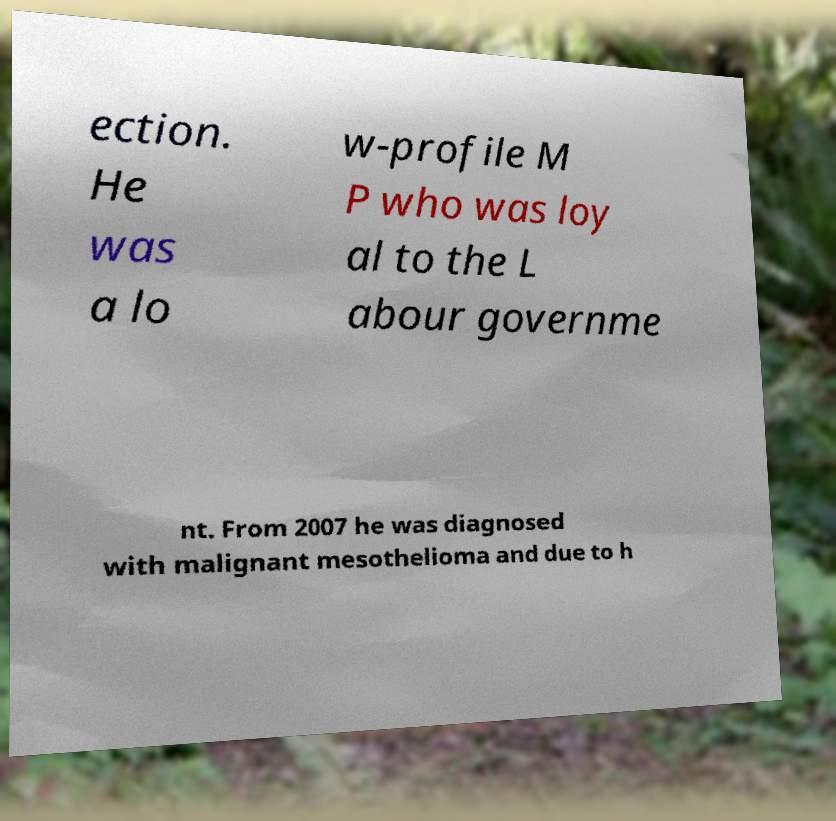Please identify and transcribe the text found in this image. ection. He was a lo w-profile M P who was loy al to the L abour governme nt. From 2007 he was diagnosed with malignant mesothelioma and due to h 